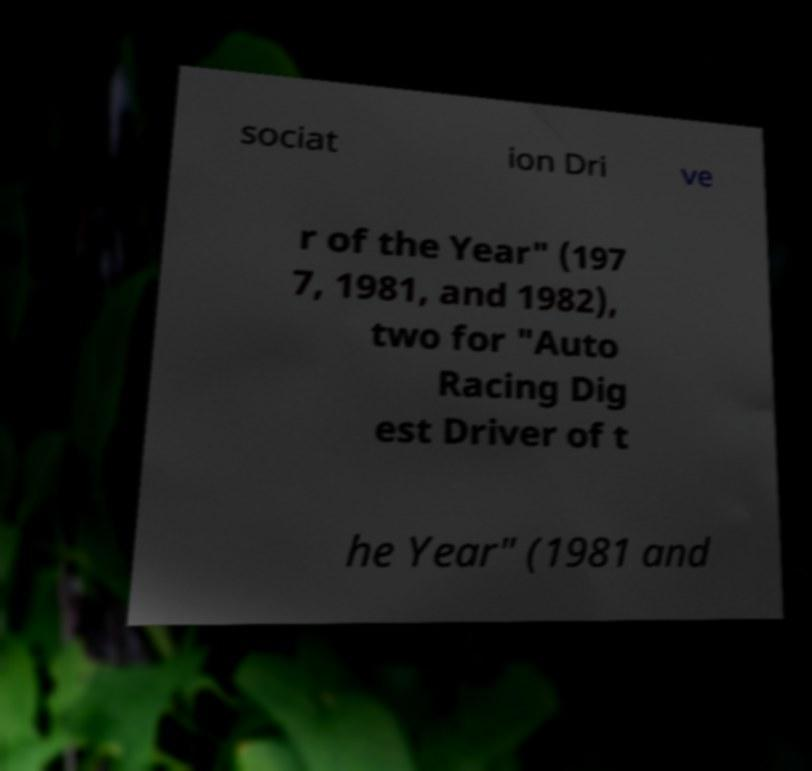Please read and relay the text visible in this image. What does it say? sociat ion Dri ve r of the Year" (197 7, 1981, and 1982), two for "Auto Racing Dig est Driver of t he Year" (1981 and 